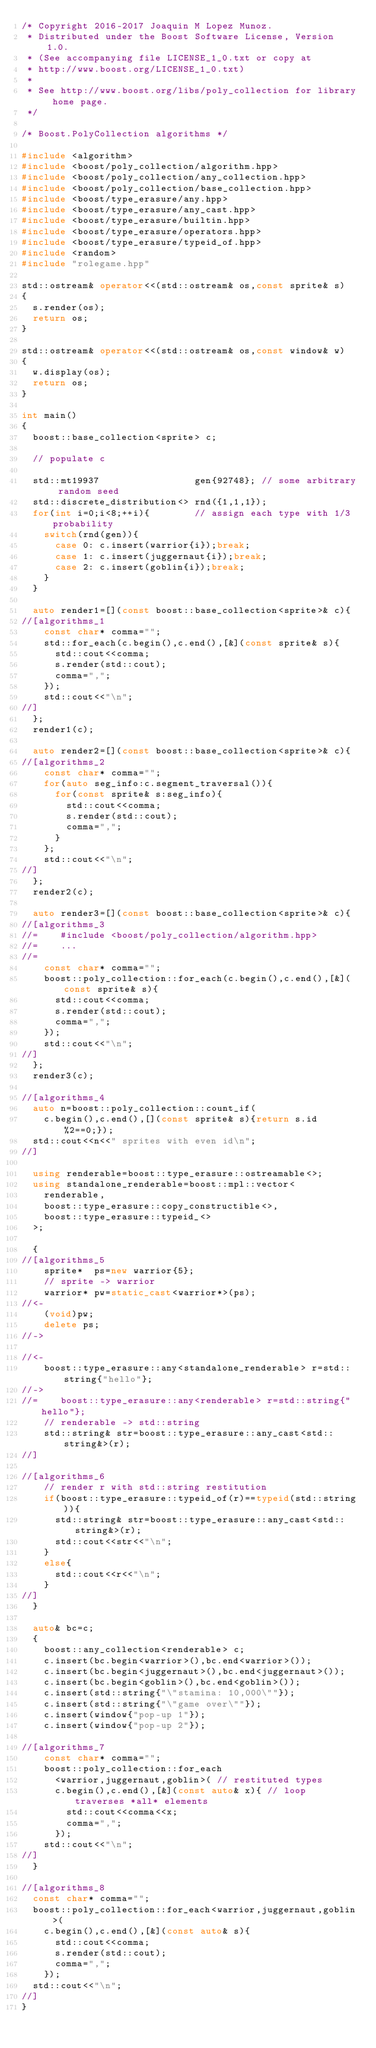Convert code to text. <code><loc_0><loc_0><loc_500><loc_500><_C++_>/* Copyright 2016-2017 Joaquin M Lopez Munoz.
 * Distributed under the Boost Software License, Version 1.0.
 * (See accompanying file LICENSE_1_0.txt or copy at
 * http://www.boost.org/LICENSE_1_0.txt)
 *
 * See http://www.boost.org/libs/poly_collection for library home page.
 */

/* Boost.PolyCollection algorithms */

#include <algorithm>
#include <boost/poly_collection/algorithm.hpp>
#include <boost/poly_collection/any_collection.hpp>
#include <boost/poly_collection/base_collection.hpp>
#include <boost/type_erasure/any.hpp>
#include <boost/type_erasure/any_cast.hpp>
#include <boost/type_erasure/builtin.hpp>
#include <boost/type_erasure/operators.hpp>
#include <boost/type_erasure/typeid_of.hpp>
#include <random>
#include "rolegame.hpp"

std::ostream& operator<<(std::ostream& os,const sprite& s)
{
  s.render(os);
  return os;
}

std::ostream& operator<<(std::ostream& os,const window& w)
{
  w.display(os);
  return os;
}

int main()
{
  boost::base_collection<sprite> c;

  // populate c

  std::mt19937                 gen{92748}; // some arbitrary random seed
  std::discrete_distribution<> rnd({1,1,1});
  for(int i=0;i<8;++i){        // assign each type with 1/3 probability
    switch(rnd(gen)){ 
      case 0: c.insert(warrior{i});break;
      case 1: c.insert(juggernaut{i});break;
      case 2: c.insert(goblin{i});break;
    }
  }

  auto render1=[](const boost::base_collection<sprite>& c){
//[algorithms_1
    const char* comma="";
    std::for_each(c.begin(),c.end(),[&](const sprite& s){
      std::cout<<comma;
      s.render(std::cout);
      comma=",";
    });
    std::cout<<"\n";
//]
  };
  render1(c);

  auto render2=[](const boost::base_collection<sprite>& c){
//[algorithms_2
    const char* comma="";
    for(auto seg_info:c.segment_traversal()){
      for(const sprite& s:seg_info){
        std::cout<<comma;
        s.render(std::cout);
        comma=",";
      }
    };
    std::cout<<"\n";
//]
  };
  render2(c);

  auto render3=[](const boost::base_collection<sprite>& c){
//[algorithms_3
//=    #include <boost/poly_collection/algorithm.hpp>
//=    ...
//=
    const char* comma="";
    boost::poly_collection::for_each(c.begin(),c.end(),[&](const sprite& s){
      std::cout<<comma;
      s.render(std::cout);
      comma=",";
    });
    std::cout<<"\n";
//]
  };
  render3(c);

//[algorithms_4
  auto n=boost::poly_collection::count_if(
    c.begin(),c.end(),[](const sprite& s){return s.id%2==0;});
  std::cout<<n<<" sprites with even id\n";
//]

  using renderable=boost::type_erasure::ostreamable<>;
  using standalone_renderable=boost::mpl::vector<
    renderable,
    boost::type_erasure::copy_constructible<>,
    boost::type_erasure::typeid_<>
  >;

  {
//[algorithms_5
    sprite*  ps=new warrior{5};
    // sprite -> warrior
    warrior* pw=static_cast<warrior*>(ps);
//<-
    (void)pw;
    delete ps;
//->

//<-
    boost::type_erasure::any<standalone_renderable> r=std::string{"hello"};
//->
//=    boost::type_erasure::any<renderable> r=std::string{"hello"};
    // renderable -> std::string
    std::string& str=boost::type_erasure::any_cast<std::string&>(r);
//]

//[algorithms_6
    // render r with std::string restitution
    if(boost::type_erasure::typeid_of(r)==typeid(std::string)){
      std::string& str=boost::type_erasure::any_cast<std::string&>(r);
      std::cout<<str<<"\n";
    }
    else{
      std::cout<<r<<"\n";
    }
//]
  }

  auto& bc=c;
  {
    boost::any_collection<renderable> c;
    c.insert(bc.begin<warrior>(),bc.end<warrior>());
    c.insert(bc.begin<juggernaut>(),bc.end<juggernaut>());
    c.insert(bc.begin<goblin>(),bc.end<goblin>());
    c.insert(std::string{"\"stamina: 10,000\""});
    c.insert(std::string{"\"game over\""});
    c.insert(window{"pop-up 1"});
    c.insert(window{"pop-up 2"});

//[algorithms_7
    const char* comma="";
    boost::poly_collection::for_each
      <warrior,juggernaut,goblin>( // restituted types
      c.begin(),c.end(),[&](const auto& x){ // loop traverses *all* elements
        std::cout<<comma<<x;
        comma=",";
      });
    std::cout<<"\n";
//]
  }

//[algorithms_8
  const char* comma="";
  boost::poly_collection::for_each<warrior,juggernaut,goblin>(
    c.begin(),c.end(),[&](const auto& s){
      std::cout<<comma;
      s.render(std::cout);
      comma=",";
    });
  std::cout<<"\n";
//]
}
</code> 